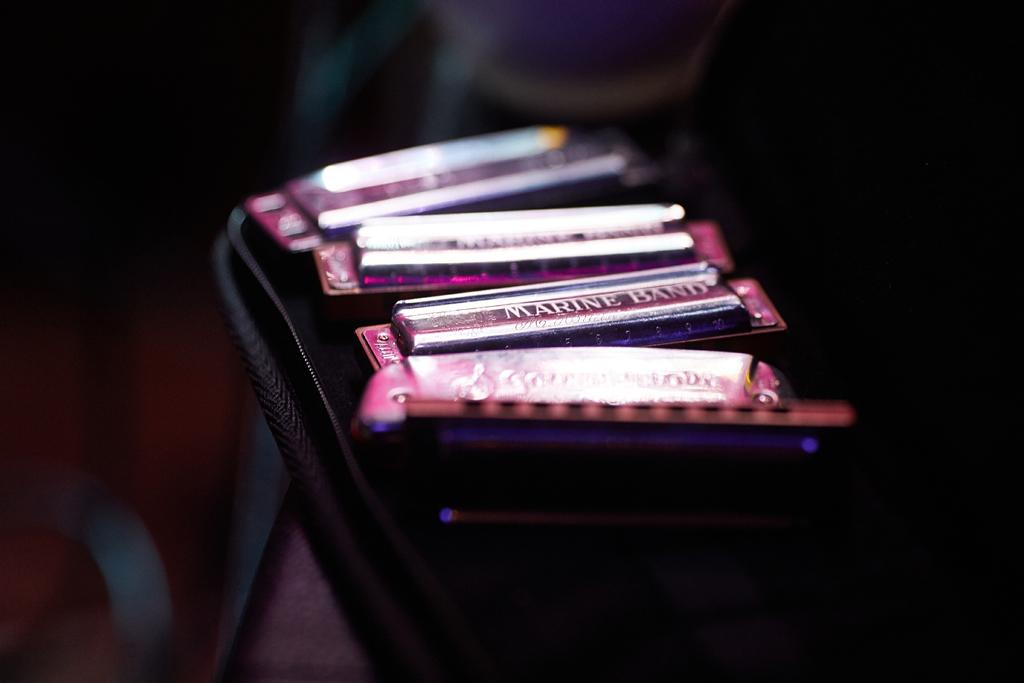What color are the objects in the image? The objects in the image are pink. Where are the pink objects placed? The pink objects are placed in a black case. What can be seen in the background of the image? The backdrop of the image is dark. What type of wilderness can be seen in the image? There is no wilderness present in the image; it features pink objects placed in a black case with a dark backdrop. Is the queen present in the image? There is no reference to a queen or any person in the image, only pink objects in a black case and a dark backdrop. 